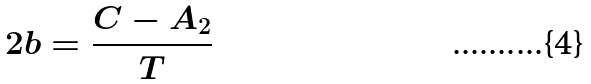<formula> <loc_0><loc_0><loc_500><loc_500>2 b = \frac { C - A _ { 2 } } T</formula> 